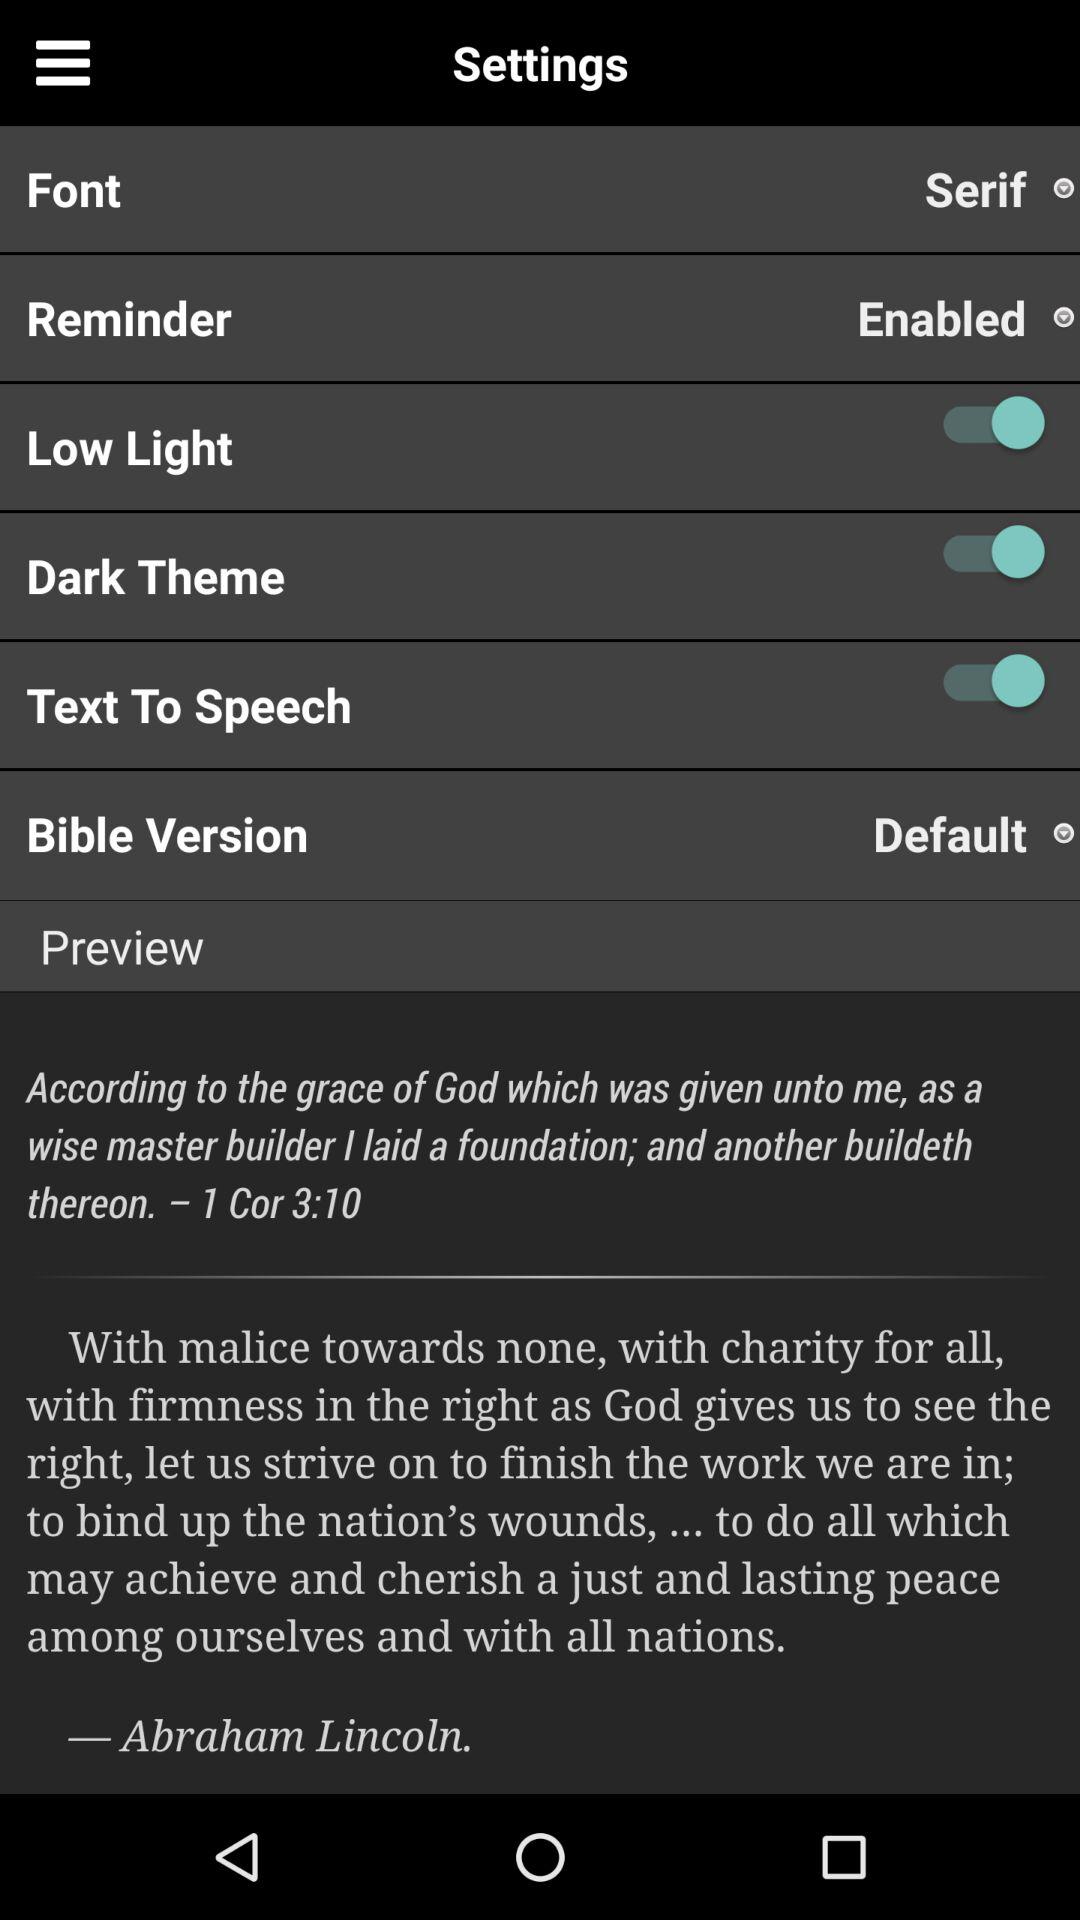Who is the author? The author is Abraham Lincoln. 